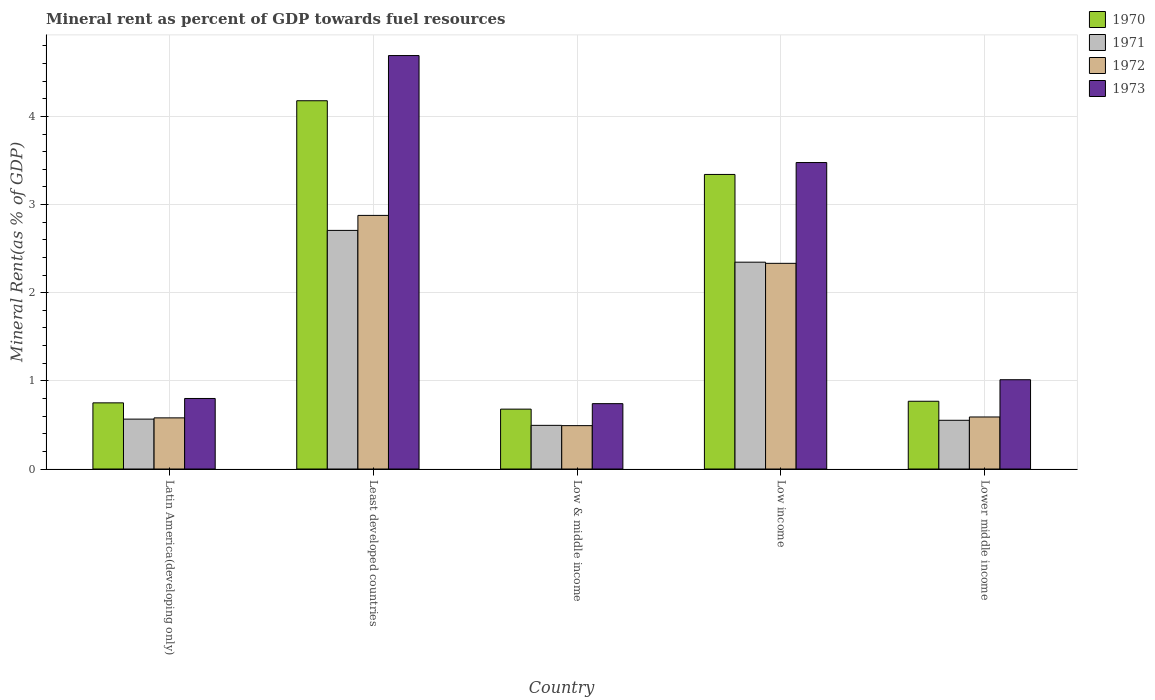Are the number of bars per tick equal to the number of legend labels?
Offer a terse response. Yes. Are the number of bars on each tick of the X-axis equal?
Ensure brevity in your answer.  Yes. How many bars are there on the 1st tick from the left?
Keep it short and to the point. 4. What is the mineral rent in 1972 in Low & middle income?
Keep it short and to the point. 0.49. Across all countries, what is the maximum mineral rent in 1971?
Offer a terse response. 2.71. Across all countries, what is the minimum mineral rent in 1970?
Keep it short and to the point. 0.68. In which country was the mineral rent in 1970 maximum?
Offer a very short reply. Least developed countries. What is the total mineral rent in 1972 in the graph?
Your answer should be compact. 6.87. What is the difference between the mineral rent in 1970 in Latin America(developing only) and that in Lower middle income?
Your response must be concise. -0.02. What is the difference between the mineral rent in 1971 in Lower middle income and the mineral rent in 1973 in Latin America(developing only)?
Provide a short and direct response. -0.25. What is the average mineral rent in 1971 per country?
Offer a terse response. 1.33. What is the difference between the mineral rent of/in 1972 and mineral rent of/in 1973 in Low income?
Your answer should be compact. -1.14. What is the ratio of the mineral rent in 1971 in Low & middle income to that in Low income?
Ensure brevity in your answer.  0.21. Is the mineral rent in 1971 in Latin America(developing only) less than that in Low income?
Keep it short and to the point. Yes. What is the difference between the highest and the second highest mineral rent in 1973?
Offer a very short reply. -2.46. What is the difference between the highest and the lowest mineral rent in 1972?
Provide a short and direct response. 2.38. In how many countries, is the mineral rent in 1973 greater than the average mineral rent in 1973 taken over all countries?
Provide a succinct answer. 2. Is the sum of the mineral rent in 1973 in Latin America(developing only) and Lower middle income greater than the maximum mineral rent in 1970 across all countries?
Keep it short and to the point. No. What does the 3rd bar from the left in Latin America(developing only) represents?
Offer a terse response. 1972. What does the 3rd bar from the right in Latin America(developing only) represents?
Give a very brief answer. 1971. Is it the case that in every country, the sum of the mineral rent in 1971 and mineral rent in 1972 is greater than the mineral rent in 1970?
Provide a succinct answer. Yes. How many bars are there?
Your answer should be compact. 20. Are all the bars in the graph horizontal?
Provide a succinct answer. No. Are the values on the major ticks of Y-axis written in scientific E-notation?
Your answer should be compact. No. Does the graph contain grids?
Provide a succinct answer. Yes. Where does the legend appear in the graph?
Your answer should be very brief. Top right. What is the title of the graph?
Your answer should be very brief. Mineral rent as percent of GDP towards fuel resources. What is the label or title of the Y-axis?
Make the answer very short. Mineral Rent(as % of GDP). What is the Mineral Rent(as % of GDP) in 1970 in Latin America(developing only)?
Your answer should be compact. 0.75. What is the Mineral Rent(as % of GDP) of 1971 in Latin America(developing only)?
Offer a terse response. 0.57. What is the Mineral Rent(as % of GDP) in 1972 in Latin America(developing only)?
Provide a short and direct response. 0.58. What is the Mineral Rent(as % of GDP) of 1973 in Latin America(developing only)?
Provide a short and direct response. 0.8. What is the Mineral Rent(as % of GDP) of 1970 in Least developed countries?
Your answer should be very brief. 4.18. What is the Mineral Rent(as % of GDP) of 1971 in Least developed countries?
Your answer should be very brief. 2.71. What is the Mineral Rent(as % of GDP) in 1972 in Least developed countries?
Ensure brevity in your answer.  2.88. What is the Mineral Rent(as % of GDP) in 1973 in Least developed countries?
Provide a succinct answer. 4.69. What is the Mineral Rent(as % of GDP) in 1970 in Low & middle income?
Ensure brevity in your answer.  0.68. What is the Mineral Rent(as % of GDP) in 1971 in Low & middle income?
Make the answer very short. 0.5. What is the Mineral Rent(as % of GDP) of 1972 in Low & middle income?
Give a very brief answer. 0.49. What is the Mineral Rent(as % of GDP) of 1973 in Low & middle income?
Give a very brief answer. 0.74. What is the Mineral Rent(as % of GDP) of 1970 in Low income?
Your answer should be very brief. 3.34. What is the Mineral Rent(as % of GDP) of 1971 in Low income?
Keep it short and to the point. 2.35. What is the Mineral Rent(as % of GDP) in 1972 in Low income?
Your response must be concise. 2.33. What is the Mineral Rent(as % of GDP) in 1973 in Low income?
Your response must be concise. 3.48. What is the Mineral Rent(as % of GDP) of 1970 in Lower middle income?
Offer a very short reply. 0.77. What is the Mineral Rent(as % of GDP) in 1971 in Lower middle income?
Your answer should be very brief. 0.55. What is the Mineral Rent(as % of GDP) of 1972 in Lower middle income?
Make the answer very short. 0.59. What is the Mineral Rent(as % of GDP) in 1973 in Lower middle income?
Keep it short and to the point. 1.01. Across all countries, what is the maximum Mineral Rent(as % of GDP) of 1970?
Your answer should be very brief. 4.18. Across all countries, what is the maximum Mineral Rent(as % of GDP) of 1971?
Ensure brevity in your answer.  2.71. Across all countries, what is the maximum Mineral Rent(as % of GDP) of 1972?
Your answer should be compact. 2.88. Across all countries, what is the maximum Mineral Rent(as % of GDP) of 1973?
Keep it short and to the point. 4.69. Across all countries, what is the minimum Mineral Rent(as % of GDP) in 1970?
Offer a terse response. 0.68. Across all countries, what is the minimum Mineral Rent(as % of GDP) of 1971?
Your answer should be very brief. 0.5. Across all countries, what is the minimum Mineral Rent(as % of GDP) of 1972?
Keep it short and to the point. 0.49. Across all countries, what is the minimum Mineral Rent(as % of GDP) in 1973?
Give a very brief answer. 0.74. What is the total Mineral Rent(as % of GDP) of 1970 in the graph?
Keep it short and to the point. 9.72. What is the total Mineral Rent(as % of GDP) of 1971 in the graph?
Offer a terse response. 6.67. What is the total Mineral Rent(as % of GDP) in 1972 in the graph?
Your response must be concise. 6.87. What is the total Mineral Rent(as % of GDP) of 1973 in the graph?
Your answer should be very brief. 10.72. What is the difference between the Mineral Rent(as % of GDP) in 1970 in Latin America(developing only) and that in Least developed countries?
Give a very brief answer. -3.43. What is the difference between the Mineral Rent(as % of GDP) in 1971 in Latin America(developing only) and that in Least developed countries?
Your answer should be very brief. -2.14. What is the difference between the Mineral Rent(as % of GDP) of 1972 in Latin America(developing only) and that in Least developed countries?
Give a very brief answer. -2.3. What is the difference between the Mineral Rent(as % of GDP) in 1973 in Latin America(developing only) and that in Least developed countries?
Your response must be concise. -3.89. What is the difference between the Mineral Rent(as % of GDP) in 1970 in Latin America(developing only) and that in Low & middle income?
Offer a terse response. 0.07. What is the difference between the Mineral Rent(as % of GDP) of 1971 in Latin America(developing only) and that in Low & middle income?
Keep it short and to the point. 0.07. What is the difference between the Mineral Rent(as % of GDP) of 1972 in Latin America(developing only) and that in Low & middle income?
Give a very brief answer. 0.09. What is the difference between the Mineral Rent(as % of GDP) in 1973 in Latin America(developing only) and that in Low & middle income?
Ensure brevity in your answer.  0.06. What is the difference between the Mineral Rent(as % of GDP) of 1970 in Latin America(developing only) and that in Low income?
Offer a terse response. -2.59. What is the difference between the Mineral Rent(as % of GDP) of 1971 in Latin America(developing only) and that in Low income?
Make the answer very short. -1.78. What is the difference between the Mineral Rent(as % of GDP) of 1972 in Latin America(developing only) and that in Low income?
Your answer should be compact. -1.75. What is the difference between the Mineral Rent(as % of GDP) in 1973 in Latin America(developing only) and that in Low income?
Ensure brevity in your answer.  -2.68. What is the difference between the Mineral Rent(as % of GDP) in 1970 in Latin America(developing only) and that in Lower middle income?
Give a very brief answer. -0.02. What is the difference between the Mineral Rent(as % of GDP) of 1971 in Latin America(developing only) and that in Lower middle income?
Offer a terse response. 0.01. What is the difference between the Mineral Rent(as % of GDP) in 1972 in Latin America(developing only) and that in Lower middle income?
Ensure brevity in your answer.  -0.01. What is the difference between the Mineral Rent(as % of GDP) of 1973 in Latin America(developing only) and that in Lower middle income?
Offer a very short reply. -0.21. What is the difference between the Mineral Rent(as % of GDP) of 1970 in Least developed countries and that in Low & middle income?
Keep it short and to the point. 3.5. What is the difference between the Mineral Rent(as % of GDP) of 1971 in Least developed countries and that in Low & middle income?
Provide a succinct answer. 2.21. What is the difference between the Mineral Rent(as % of GDP) in 1972 in Least developed countries and that in Low & middle income?
Provide a succinct answer. 2.38. What is the difference between the Mineral Rent(as % of GDP) of 1973 in Least developed countries and that in Low & middle income?
Offer a terse response. 3.95. What is the difference between the Mineral Rent(as % of GDP) of 1970 in Least developed countries and that in Low income?
Offer a very short reply. 0.84. What is the difference between the Mineral Rent(as % of GDP) in 1971 in Least developed countries and that in Low income?
Your answer should be very brief. 0.36. What is the difference between the Mineral Rent(as % of GDP) in 1972 in Least developed countries and that in Low income?
Provide a succinct answer. 0.54. What is the difference between the Mineral Rent(as % of GDP) of 1973 in Least developed countries and that in Low income?
Your response must be concise. 1.21. What is the difference between the Mineral Rent(as % of GDP) of 1970 in Least developed countries and that in Lower middle income?
Offer a very short reply. 3.41. What is the difference between the Mineral Rent(as % of GDP) in 1971 in Least developed countries and that in Lower middle income?
Your answer should be compact. 2.15. What is the difference between the Mineral Rent(as % of GDP) in 1972 in Least developed countries and that in Lower middle income?
Provide a succinct answer. 2.29. What is the difference between the Mineral Rent(as % of GDP) in 1973 in Least developed countries and that in Lower middle income?
Give a very brief answer. 3.68. What is the difference between the Mineral Rent(as % of GDP) of 1970 in Low & middle income and that in Low income?
Offer a very short reply. -2.66. What is the difference between the Mineral Rent(as % of GDP) in 1971 in Low & middle income and that in Low income?
Give a very brief answer. -1.85. What is the difference between the Mineral Rent(as % of GDP) in 1972 in Low & middle income and that in Low income?
Make the answer very short. -1.84. What is the difference between the Mineral Rent(as % of GDP) in 1973 in Low & middle income and that in Low income?
Your answer should be compact. -2.73. What is the difference between the Mineral Rent(as % of GDP) in 1970 in Low & middle income and that in Lower middle income?
Make the answer very short. -0.09. What is the difference between the Mineral Rent(as % of GDP) of 1971 in Low & middle income and that in Lower middle income?
Your answer should be very brief. -0.06. What is the difference between the Mineral Rent(as % of GDP) of 1972 in Low & middle income and that in Lower middle income?
Provide a succinct answer. -0.1. What is the difference between the Mineral Rent(as % of GDP) in 1973 in Low & middle income and that in Lower middle income?
Your answer should be very brief. -0.27. What is the difference between the Mineral Rent(as % of GDP) of 1970 in Low income and that in Lower middle income?
Make the answer very short. 2.57. What is the difference between the Mineral Rent(as % of GDP) in 1971 in Low income and that in Lower middle income?
Make the answer very short. 1.79. What is the difference between the Mineral Rent(as % of GDP) in 1972 in Low income and that in Lower middle income?
Your response must be concise. 1.74. What is the difference between the Mineral Rent(as % of GDP) in 1973 in Low income and that in Lower middle income?
Your answer should be very brief. 2.46. What is the difference between the Mineral Rent(as % of GDP) in 1970 in Latin America(developing only) and the Mineral Rent(as % of GDP) in 1971 in Least developed countries?
Your answer should be compact. -1.96. What is the difference between the Mineral Rent(as % of GDP) in 1970 in Latin America(developing only) and the Mineral Rent(as % of GDP) in 1972 in Least developed countries?
Keep it short and to the point. -2.13. What is the difference between the Mineral Rent(as % of GDP) in 1970 in Latin America(developing only) and the Mineral Rent(as % of GDP) in 1973 in Least developed countries?
Ensure brevity in your answer.  -3.94. What is the difference between the Mineral Rent(as % of GDP) in 1971 in Latin America(developing only) and the Mineral Rent(as % of GDP) in 1972 in Least developed countries?
Give a very brief answer. -2.31. What is the difference between the Mineral Rent(as % of GDP) of 1971 in Latin America(developing only) and the Mineral Rent(as % of GDP) of 1973 in Least developed countries?
Your answer should be compact. -4.12. What is the difference between the Mineral Rent(as % of GDP) of 1972 in Latin America(developing only) and the Mineral Rent(as % of GDP) of 1973 in Least developed countries?
Your answer should be very brief. -4.11. What is the difference between the Mineral Rent(as % of GDP) in 1970 in Latin America(developing only) and the Mineral Rent(as % of GDP) in 1971 in Low & middle income?
Your answer should be very brief. 0.26. What is the difference between the Mineral Rent(as % of GDP) of 1970 in Latin America(developing only) and the Mineral Rent(as % of GDP) of 1972 in Low & middle income?
Your answer should be compact. 0.26. What is the difference between the Mineral Rent(as % of GDP) in 1970 in Latin America(developing only) and the Mineral Rent(as % of GDP) in 1973 in Low & middle income?
Make the answer very short. 0.01. What is the difference between the Mineral Rent(as % of GDP) in 1971 in Latin America(developing only) and the Mineral Rent(as % of GDP) in 1972 in Low & middle income?
Provide a succinct answer. 0.07. What is the difference between the Mineral Rent(as % of GDP) of 1971 in Latin America(developing only) and the Mineral Rent(as % of GDP) of 1973 in Low & middle income?
Keep it short and to the point. -0.18. What is the difference between the Mineral Rent(as % of GDP) of 1972 in Latin America(developing only) and the Mineral Rent(as % of GDP) of 1973 in Low & middle income?
Ensure brevity in your answer.  -0.16. What is the difference between the Mineral Rent(as % of GDP) of 1970 in Latin America(developing only) and the Mineral Rent(as % of GDP) of 1971 in Low income?
Make the answer very short. -1.6. What is the difference between the Mineral Rent(as % of GDP) in 1970 in Latin America(developing only) and the Mineral Rent(as % of GDP) in 1972 in Low income?
Ensure brevity in your answer.  -1.58. What is the difference between the Mineral Rent(as % of GDP) in 1970 in Latin America(developing only) and the Mineral Rent(as % of GDP) in 1973 in Low income?
Offer a terse response. -2.73. What is the difference between the Mineral Rent(as % of GDP) in 1971 in Latin America(developing only) and the Mineral Rent(as % of GDP) in 1972 in Low income?
Provide a succinct answer. -1.77. What is the difference between the Mineral Rent(as % of GDP) in 1971 in Latin America(developing only) and the Mineral Rent(as % of GDP) in 1973 in Low income?
Keep it short and to the point. -2.91. What is the difference between the Mineral Rent(as % of GDP) of 1972 in Latin America(developing only) and the Mineral Rent(as % of GDP) of 1973 in Low income?
Offer a very short reply. -2.9. What is the difference between the Mineral Rent(as % of GDP) in 1970 in Latin America(developing only) and the Mineral Rent(as % of GDP) in 1971 in Lower middle income?
Give a very brief answer. 0.2. What is the difference between the Mineral Rent(as % of GDP) of 1970 in Latin America(developing only) and the Mineral Rent(as % of GDP) of 1972 in Lower middle income?
Your answer should be compact. 0.16. What is the difference between the Mineral Rent(as % of GDP) in 1970 in Latin America(developing only) and the Mineral Rent(as % of GDP) in 1973 in Lower middle income?
Give a very brief answer. -0.26. What is the difference between the Mineral Rent(as % of GDP) in 1971 in Latin America(developing only) and the Mineral Rent(as % of GDP) in 1972 in Lower middle income?
Provide a short and direct response. -0.02. What is the difference between the Mineral Rent(as % of GDP) of 1971 in Latin America(developing only) and the Mineral Rent(as % of GDP) of 1973 in Lower middle income?
Give a very brief answer. -0.45. What is the difference between the Mineral Rent(as % of GDP) of 1972 in Latin America(developing only) and the Mineral Rent(as % of GDP) of 1973 in Lower middle income?
Give a very brief answer. -0.43. What is the difference between the Mineral Rent(as % of GDP) in 1970 in Least developed countries and the Mineral Rent(as % of GDP) in 1971 in Low & middle income?
Give a very brief answer. 3.68. What is the difference between the Mineral Rent(as % of GDP) in 1970 in Least developed countries and the Mineral Rent(as % of GDP) in 1972 in Low & middle income?
Give a very brief answer. 3.69. What is the difference between the Mineral Rent(as % of GDP) in 1970 in Least developed countries and the Mineral Rent(as % of GDP) in 1973 in Low & middle income?
Keep it short and to the point. 3.44. What is the difference between the Mineral Rent(as % of GDP) of 1971 in Least developed countries and the Mineral Rent(as % of GDP) of 1972 in Low & middle income?
Your answer should be compact. 2.21. What is the difference between the Mineral Rent(as % of GDP) in 1971 in Least developed countries and the Mineral Rent(as % of GDP) in 1973 in Low & middle income?
Your answer should be compact. 1.97. What is the difference between the Mineral Rent(as % of GDP) of 1972 in Least developed countries and the Mineral Rent(as % of GDP) of 1973 in Low & middle income?
Provide a short and direct response. 2.14. What is the difference between the Mineral Rent(as % of GDP) in 1970 in Least developed countries and the Mineral Rent(as % of GDP) in 1971 in Low income?
Your answer should be compact. 1.83. What is the difference between the Mineral Rent(as % of GDP) of 1970 in Least developed countries and the Mineral Rent(as % of GDP) of 1972 in Low income?
Keep it short and to the point. 1.84. What is the difference between the Mineral Rent(as % of GDP) of 1970 in Least developed countries and the Mineral Rent(as % of GDP) of 1973 in Low income?
Your response must be concise. 0.7. What is the difference between the Mineral Rent(as % of GDP) of 1971 in Least developed countries and the Mineral Rent(as % of GDP) of 1972 in Low income?
Keep it short and to the point. 0.37. What is the difference between the Mineral Rent(as % of GDP) of 1971 in Least developed countries and the Mineral Rent(as % of GDP) of 1973 in Low income?
Offer a very short reply. -0.77. What is the difference between the Mineral Rent(as % of GDP) of 1972 in Least developed countries and the Mineral Rent(as % of GDP) of 1973 in Low income?
Your response must be concise. -0.6. What is the difference between the Mineral Rent(as % of GDP) in 1970 in Least developed countries and the Mineral Rent(as % of GDP) in 1971 in Lower middle income?
Keep it short and to the point. 3.62. What is the difference between the Mineral Rent(as % of GDP) in 1970 in Least developed countries and the Mineral Rent(as % of GDP) in 1972 in Lower middle income?
Keep it short and to the point. 3.59. What is the difference between the Mineral Rent(as % of GDP) of 1970 in Least developed countries and the Mineral Rent(as % of GDP) of 1973 in Lower middle income?
Give a very brief answer. 3.16. What is the difference between the Mineral Rent(as % of GDP) in 1971 in Least developed countries and the Mineral Rent(as % of GDP) in 1972 in Lower middle income?
Provide a short and direct response. 2.12. What is the difference between the Mineral Rent(as % of GDP) of 1971 in Least developed countries and the Mineral Rent(as % of GDP) of 1973 in Lower middle income?
Make the answer very short. 1.69. What is the difference between the Mineral Rent(as % of GDP) in 1972 in Least developed countries and the Mineral Rent(as % of GDP) in 1973 in Lower middle income?
Make the answer very short. 1.86. What is the difference between the Mineral Rent(as % of GDP) of 1970 in Low & middle income and the Mineral Rent(as % of GDP) of 1971 in Low income?
Keep it short and to the point. -1.67. What is the difference between the Mineral Rent(as % of GDP) in 1970 in Low & middle income and the Mineral Rent(as % of GDP) in 1972 in Low income?
Ensure brevity in your answer.  -1.65. What is the difference between the Mineral Rent(as % of GDP) in 1970 in Low & middle income and the Mineral Rent(as % of GDP) in 1973 in Low income?
Offer a very short reply. -2.8. What is the difference between the Mineral Rent(as % of GDP) in 1971 in Low & middle income and the Mineral Rent(as % of GDP) in 1972 in Low income?
Your answer should be compact. -1.84. What is the difference between the Mineral Rent(as % of GDP) of 1971 in Low & middle income and the Mineral Rent(as % of GDP) of 1973 in Low income?
Keep it short and to the point. -2.98. What is the difference between the Mineral Rent(as % of GDP) of 1972 in Low & middle income and the Mineral Rent(as % of GDP) of 1973 in Low income?
Keep it short and to the point. -2.98. What is the difference between the Mineral Rent(as % of GDP) of 1970 in Low & middle income and the Mineral Rent(as % of GDP) of 1971 in Lower middle income?
Ensure brevity in your answer.  0.13. What is the difference between the Mineral Rent(as % of GDP) of 1970 in Low & middle income and the Mineral Rent(as % of GDP) of 1972 in Lower middle income?
Offer a terse response. 0.09. What is the difference between the Mineral Rent(as % of GDP) of 1970 in Low & middle income and the Mineral Rent(as % of GDP) of 1973 in Lower middle income?
Your response must be concise. -0.33. What is the difference between the Mineral Rent(as % of GDP) in 1971 in Low & middle income and the Mineral Rent(as % of GDP) in 1972 in Lower middle income?
Your response must be concise. -0.09. What is the difference between the Mineral Rent(as % of GDP) of 1971 in Low & middle income and the Mineral Rent(as % of GDP) of 1973 in Lower middle income?
Provide a succinct answer. -0.52. What is the difference between the Mineral Rent(as % of GDP) in 1972 in Low & middle income and the Mineral Rent(as % of GDP) in 1973 in Lower middle income?
Give a very brief answer. -0.52. What is the difference between the Mineral Rent(as % of GDP) of 1970 in Low income and the Mineral Rent(as % of GDP) of 1971 in Lower middle income?
Offer a terse response. 2.79. What is the difference between the Mineral Rent(as % of GDP) of 1970 in Low income and the Mineral Rent(as % of GDP) of 1972 in Lower middle income?
Give a very brief answer. 2.75. What is the difference between the Mineral Rent(as % of GDP) of 1970 in Low income and the Mineral Rent(as % of GDP) of 1973 in Lower middle income?
Offer a terse response. 2.33. What is the difference between the Mineral Rent(as % of GDP) of 1971 in Low income and the Mineral Rent(as % of GDP) of 1972 in Lower middle income?
Give a very brief answer. 1.76. What is the difference between the Mineral Rent(as % of GDP) in 1971 in Low income and the Mineral Rent(as % of GDP) in 1973 in Lower middle income?
Give a very brief answer. 1.33. What is the difference between the Mineral Rent(as % of GDP) of 1972 in Low income and the Mineral Rent(as % of GDP) of 1973 in Lower middle income?
Your answer should be very brief. 1.32. What is the average Mineral Rent(as % of GDP) of 1970 per country?
Make the answer very short. 1.94. What is the average Mineral Rent(as % of GDP) in 1971 per country?
Give a very brief answer. 1.33. What is the average Mineral Rent(as % of GDP) of 1972 per country?
Keep it short and to the point. 1.37. What is the average Mineral Rent(as % of GDP) of 1973 per country?
Give a very brief answer. 2.14. What is the difference between the Mineral Rent(as % of GDP) in 1970 and Mineral Rent(as % of GDP) in 1971 in Latin America(developing only)?
Your response must be concise. 0.18. What is the difference between the Mineral Rent(as % of GDP) in 1970 and Mineral Rent(as % of GDP) in 1972 in Latin America(developing only)?
Ensure brevity in your answer.  0.17. What is the difference between the Mineral Rent(as % of GDP) in 1970 and Mineral Rent(as % of GDP) in 1973 in Latin America(developing only)?
Keep it short and to the point. -0.05. What is the difference between the Mineral Rent(as % of GDP) in 1971 and Mineral Rent(as % of GDP) in 1972 in Latin America(developing only)?
Offer a very short reply. -0.01. What is the difference between the Mineral Rent(as % of GDP) of 1971 and Mineral Rent(as % of GDP) of 1973 in Latin America(developing only)?
Provide a succinct answer. -0.23. What is the difference between the Mineral Rent(as % of GDP) of 1972 and Mineral Rent(as % of GDP) of 1973 in Latin America(developing only)?
Provide a succinct answer. -0.22. What is the difference between the Mineral Rent(as % of GDP) in 1970 and Mineral Rent(as % of GDP) in 1971 in Least developed countries?
Make the answer very short. 1.47. What is the difference between the Mineral Rent(as % of GDP) of 1970 and Mineral Rent(as % of GDP) of 1972 in Least developed countries?
Your answer should be very brief. 1.3. What is the difference between the Mineral Rent(as % of GDP) of 1970 and Mineral Rent(as % of GDP) of 1973 in Least developed countries?
Give a very brief answer. -0.51. What is the difference between the Mineral Rent(as % of GDP) of 1971 and Mineral Rent(as % of GDP) of 1972 in Least developed countries?
Make the answer very short. -0.17. What is the difference between the Mineral Rent(as % of GDP) of 1971 and Mineral Rent(as % of GDP) of 1973 in Least developed countries?
Give a very brief answer. -1.98. What is the difference between the Mineral Rent(as % of GDP) of 1972 and Mineral Rent(as % of GDP) of 1973 in Least developed countries?
Make the answer very short. -1.81. What is the difference between the Mineral Rent(as % of GDP) of 1970 and Mineral Rent(as % of GDP) of 1971 in Low & middle income?
Offer a terse response. 0.18. What is the difference between the Mineral Rent(as % of GDP) of 1970 and Mineral Rent(as % of GDP) of 1972 in Low & middle income?
Provide a succinct answer. 0.19. What is the difference between the Mineral Rent(as % of GDP) of 1970 and Mineral Rent(as % of GDP) of 1973 in Low & middle income?
Keep it short and to the point. -0.06. What is the difference between the Mineral Rent(as % of GDP) of 1971 and Mineral Rent(as % of GDP) of 1972 in Low & middle income?
Your response must be concise. 0. What is the difference between the Mineral Rent(as % of GDP) of 1971 and Mineral Rent(as % of GDP) of 1973 in Low & middle income?
Your response must be concise. -0.25. What is the difference between the Mineral Rent(as % of GDP) in 1972 and Mineral Rent(as % of GDP) in 1973 in Low & middle income?
Provide a short and direct response. -0.25. What is the difference between the Mineral Rent(as % of GDP) in 1970 and Mineral Rent(as % of GDP) in 1972 in Low income?
Offer a terse response. 1.01. What is the difference between the Mineral Rent(as % of GDP) of 1970 and Mineral Rent(as % of GDP) of 1973 in Low income?
Your response must be concise. -0.14. What is the difference between the Mineral Rent(as % of GDP) in 1971 and Mineral Rent(as % of GDP) in 1972 in Low income?
Your response must be concise. 0.01. What is the difference between the Mineral Rent(as % of GDP) in 1971 and Mineral Rent(as % of GDP) in 1973 in Low income?
Your answer should be very brief. -1.13. What is the difference between the Mineral Rent(as % of GDP) of 1972 and Mineral Rent(as % of GDP) of 1973 in Low income?
Ensure brevity in your answer.  -1.14. What is the difference between the Mineral Rent(as % of GDP) of 1970 and Mineral Rent(as % of GDP) of 1971 in Lower middle income?
Give a very brief answer. 0.22. What is the difference between the Mineral Rent(as % of GDP) of 1970 and Mineral Rent(as % of GDP) of 1972 in Lower middle income?
Offer a very short reply. 0.18. What is the difference between the Mineral Rent(as % of GDP) of 1970 and Mineral Rent(as % of GDP) of 1973 in Lower middle income?
Ensure brevity in your answer.  -0.24. What is the difference between the Mineral Rent(as % of GDP) in 1971 and Mineral Rent(as % of GDP) in 1972 in Lower middle income?
Make the answer very short. -0.04. What is the difference between the Mineral Rent(as % of GDP) in 1971 and Mineral Rent(as % of GDP) in 1973 in Lower middle income?
Provide a short and direct response. -0.46. What is the difference between the Mineral Rent(as % of GDP) in 1972 and Mineral Rent(as % of GDP) in 1973 in Lower middle income?
Offer a terse response. -0.42. What is the ratio of the Mineral Rent(as % of GDP) in 1970 in Latin America(developing only) to that in Least developed countries?
Make the answer very short. 0.18. What is the ratio of the Mineral Rent(as % of GDP) of 1971 in Latin America(developing only) to that in Least developed countries?
Provide a succinct answer. 0.21. What is the ratio of the Mineral Rent(as % of GDP) in 1972 in Latin America(developing only) to that in Least developed countries?
Provide a short and direct response. 0.2. What is the ratio of the Mineral Rent(as % of GDP) in 1973 in Latin America(developing only) to that in Least developed countries?
Provide a succinct answer. 0.17. What is the ratio of the Mineral Rent(as % of GDP) in 1970 in Latin America(developing only) to that in Low & middle income?
Offer a very short reply. 1.1. What is the ratio of the Mineral Rent(as % of GDP) in 1971 in Latin America(developing only) to that in Low & middle income?
Give a very brief answer. 1.14. What is the ratio of the Mineral Rent(as % of GDP) of 1972 in Latin America(developing only) to that in Low & middle income?
Provide a succinct answer. 1.18. What is the ratio of the Mineral Rent(as % of GDP) in 1973 in Latin America(developing only) to that in Low & middle income?
Give a very brief answer. 1.08. What is the ratio of the Mineral Rent(as % of GDP) in 1970 in Latin America(developing only) to that in Low income?
Offer a very short reply. 0.22. What is the ratio of the Mineral Rent(as % of GDP) of 1971 in Latin America(developing only) to that in Low income?
Offer a terse response. 0.24. What is the ratio of the Mineral Rent(as % of GDP) of 1972 in Latin America(developing only) to that in Low income?
Your answer should be very brief. 0.25. What is the ratio of the Mineral Rent(as % of GDP) in 1973 in Latin America(developing only) to that in Low income?
Your response must be concise. 0.23. What is the ratio of the Mineral Rent(as % of GDP) of 1970 in Latin America(developing only) to that in Lower middle income?
Your answer should be compact. 0.98. What is the ratio of the Mineral Rent(as % of GDP) of 1971 in Latin America(developing only) to that in Lower middle income?
Make the answer very short. 1.02. What is the ratio of the Mineral Rent(as % of GDP) in 1972 in Latin America(developing only) to that in Lower middle income?
Ensure brevity in your answer.  0.98. What is the ratio of the Mineral Rent(as % of GDP) in 1973 in Latin America(developing only) to that in Lower middle income?
Your answer should be compact. 0.79. What is the ratio of the Mineral Rent(as % of GDP) in 1970 in Least developed countries to that in Low & middle income?
Your response must be concise. 6.15. What is the ratio of the Mineral Rent(as % of GDP) of 1971 in Least developed countries to that in Low & middle income?
Your answer should be very brief. 5.46. What is the ratio of the Mineral Rent(as % of GDP) of 1972 in Least developed countries to that in Low & middle income?
Provide a succinct answer. 5.85. What is the ratio of the Mineral Rent(as % of GDP) in 1973 in Least developed countries to that in Low & middle income?
Ensure brevity in your answer.  6.33. What is the ratio of the Mineral Rent(as % of GDP) in 1970 in Least developed countries to that in Low income?
Your answer should be very brief. 1.25. What is the ratio of the Mineral Rent(as % of GDP) in 1971 in Least developed countries to that in Low income?
Provide a short and direct response. 1.15. What is the ratio of the Mineral Rent(as % of GDP) in 1972 in Least developed countries to that in Low income?
Provide a short and direct response. 1.23. What is the ratio of the Mineral Rent(as % of GDP) in 1973 in Least developed countries to that in Low income?
Provide a short and direct response. 1.35. What is the ratio of the Mineral Rent(as % of GDP) of 1970 in Least developed countries to that in Lower middle income?
Offer a very short reply. 5.44. What is the ratio of the Mineral Rent(as % of GDP) of 1971 in Least developed countries to that in Lower middle income?
Offer a terse response. 4.9. What is the ratio of the Mineral Rent(as % of GDP) of 1972 in Least developed countries to that in Lower middle income?
Make the answer very short. 4.87. What is the ratio of the Mineral Rent(as % of GDP) in 1973 in Least developed countries to that in Lower middle income?
Make the answer very short. 4.63. What is the ratio of the Mineral Rent(as % of GDP) of 1970 in Low & middle income to that in Low income?
Keep it short and to the point. 0.2. What is the ratio of the Mineral Rent(as % of GDP) of 1971 in Low & middle income to that in Low income?
Provide a succinct answer. 0.21. What is the ratio of the Mineral Rent(as % of GDP) in 1972 in Low & middle income to that in Low income?
Ensure brevity in your answer.  0.21. What is the ratio of the Mineral Rent(as % of GDP) of 1973 in Low & middle income to that in Low income?
Your answer should be very brief. 0.21. What is the ratio of the Mineral Rent(as % of GDP) in 1970 in Low & middle income to that in Lower middle income?
Give a very brief answer. 0.88. What is the ratio of the Mineral Rent(as % of GDP) in 1971 in Low & middle income to that in Lower middle income?
Keep it short and to the point. 0.9. What is the ratio of the Mineral Rent(as % of GDP) in 1972 in Low & middle income to that in Lower middle income?
Give a very brief answer. 0.83. What is the ratio of the Mineral Rent(as % of GDP) in 1973 in Low & middle income to that in Lower middle income?
Ensure brevity in your answer.  0.73. What is the ratio of the Mineral Rent(as % of GDP) in 1970 in Low income to that in Lower middle income?
Make the answer very short. 4.35. What is the ratio of the Mineral Rent(as % of GDP) of 1971 in Low income to that in Lower middle income?
Offer a very short reply. 4.25. What is the ratio of the Mineral Rent(as % of GDP) in 1972 in Low income to that in Lower middle income?
Offer a very short reply. 3.95. What is the ratio of the Mineral Rent(as % of GDP) of 1973 in Low income to that in Lower middle income?
Provide a succinct answer. 3.43. What is the difference between the highest and the second highest Mineral Rent(as % of GDP) of 1970?
Ensure brevity in your answer.  0.84. What is the difference between the highest and the second highest Mineral Rent(as % of GDP) in 1971?
Provide a short and direct response. 0.36. What is the difference between the highest and the second highest Mineral Rent(as % of GDP) of 1972?
Provide a short and direct response. 0.54. What is the difference between the highest and the second highest Mineral Rent(as % of GDP) in 1973?
Provide a short and direct response. 1.21. What is the difference between the highest and the lowest Mineral Rent(as % of GDP) in 1970?
Your response must be concise. 3.5. What is the difference between the highest and the lowest Mineral Rent(as % of GDP) in 1971?
Your answer should be compact. 2.21. What is the difference between the highest and the lowest Mineral Rent(as % of GDP) of 1972?
Offer a terse response. 2.38. What is the difference between the highest and the lowest Mineral Rent(as % of GDP) in 1973?
Provide a succinct answer. 3.95. 